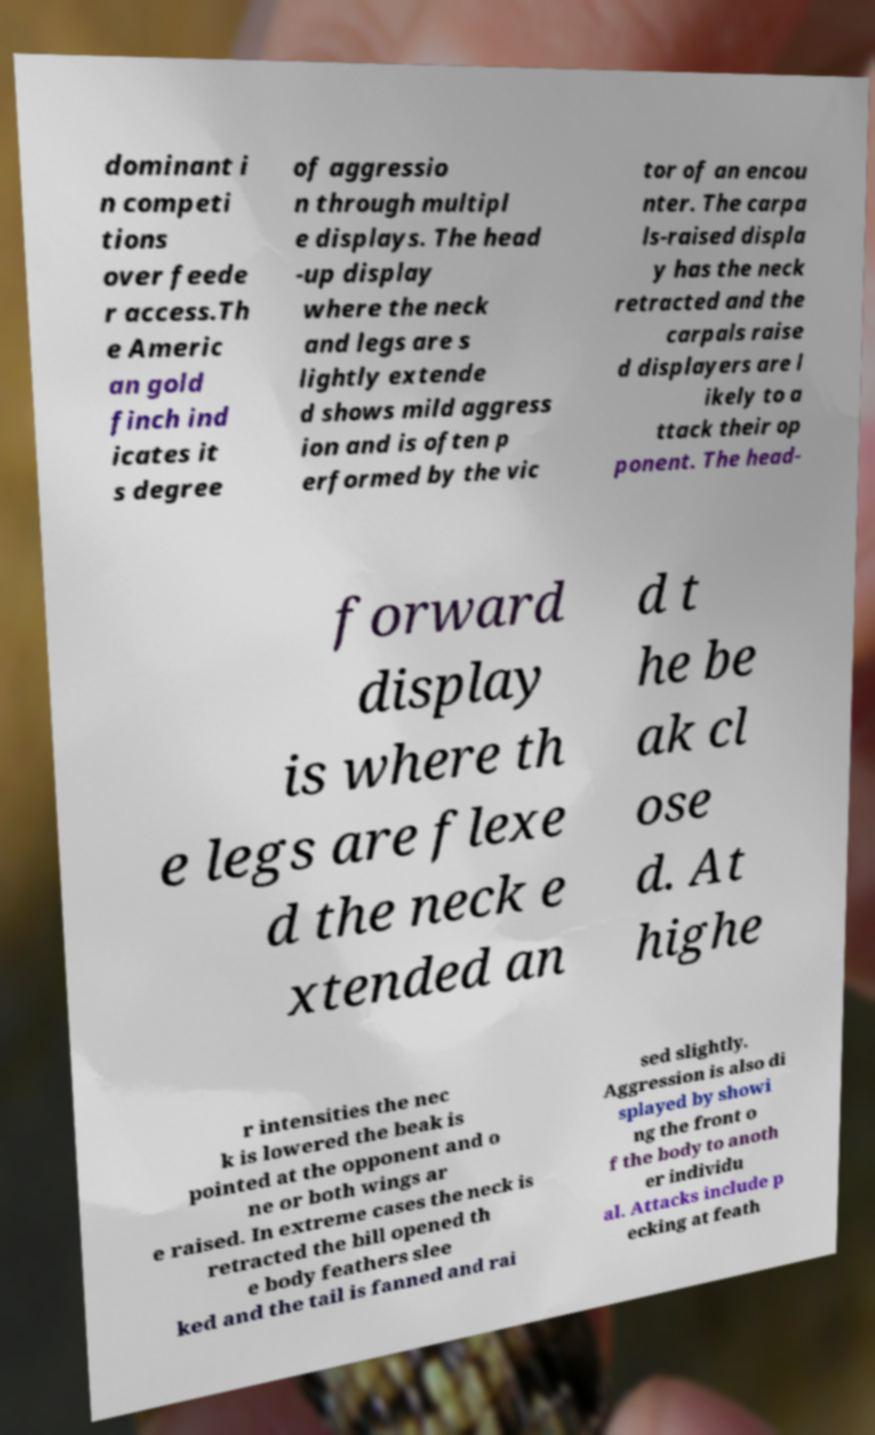Can you accurately transcribe the text from the provided image for me? dominant i n competi tions over feede r access.Th e Americ an gold finch ind icates it s degree of aggressio n through multipl e displays. The head -up display where the neck and legs are s lightly extende d shows mild aggress ion and is often p erformed by the vic tor of an encou nter. The carpa ls-raised displa y has the neck retracted and the carpals raise d displayers are l ikely to a ttack their op ponent. The head- forward display is where th e legs are flexe d the neck e xtended an d t he be ak cl ose d. At highe r intensities the nec k is lowered the beak is pointed at the opponent and o ne or both wings ar e raised. In extreme cases the neck is retracted the bill opened th e body feathers slee ked and the tail is fanned and rai sed slightly. Aggression is also di splayed by showi ng the front o f the body to anoth er individu al. Attacks include p ecking at feath 